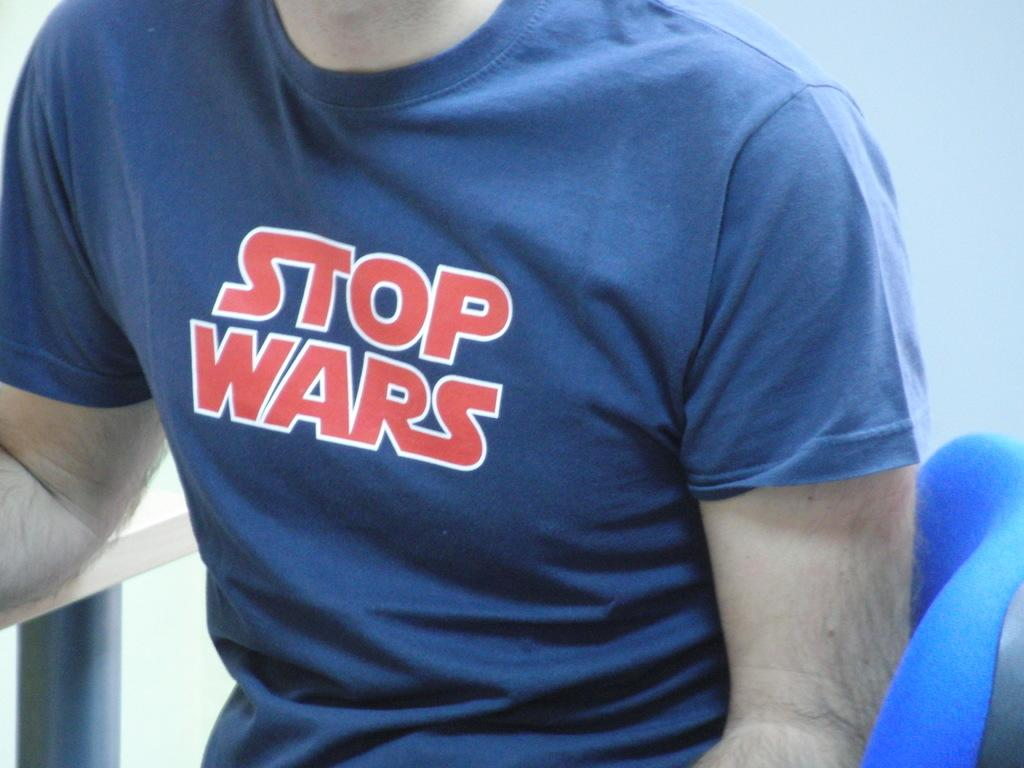<image>
Share a concise interpretation of the image provided. Person wearing a blue shirt which says Stop Wars. 